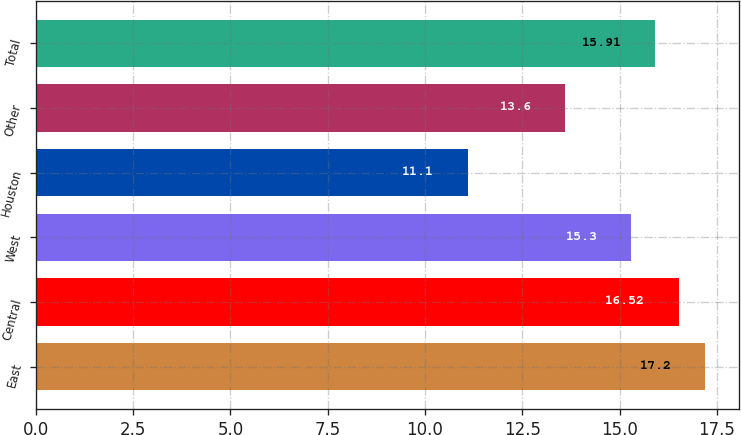Convert chart. <chart><loc_0><loc_0><loc_500><loc_500><bar_chart><fcel>East<fcel>Central<fcel>West<fcel>Houston<fcel>Other<fcel>Total<nl><fcel>17.2<fcel>16.52<fcel>15.3<fcel>11.1<fcel>13.6<fcel>15.91<nl></chart> 